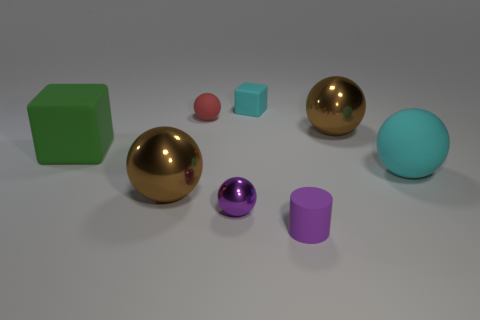Is there another ball that has the same color as the large rubber sphere?
Provide a succinct answer. No. There is a matte cube that is to the left of the purple metal object; does it have the same size as the small purple metal object?
Provide a succinct answer. No. What is the color of the tiny cube?
Your response must be concise. Cyan. There is a matte ball that is on the left side of the large brown thing to the right of the tiny matte cylinder; what color is it?
Provide a short and direct response. Red. Are there any blocks made of the same material as the big cyan sphere?
Give a very brief answer. Yes. There is a brown object that is in front of the large brown object that is behind the big cube; what is it made of?
Give a very brief answer. Metal. What number of purple things are the same shape as the big cyan thing?
Your answer should be very brief. 1. The red object has what shape?
Provide a succinct answer. Sphere. Is the number of small cyan objects less than the number of matte balls?
Provide a succinct answer. Yes. Are there any other things that are the same size as the cyan block?
Your answer should be compact. Yes. 